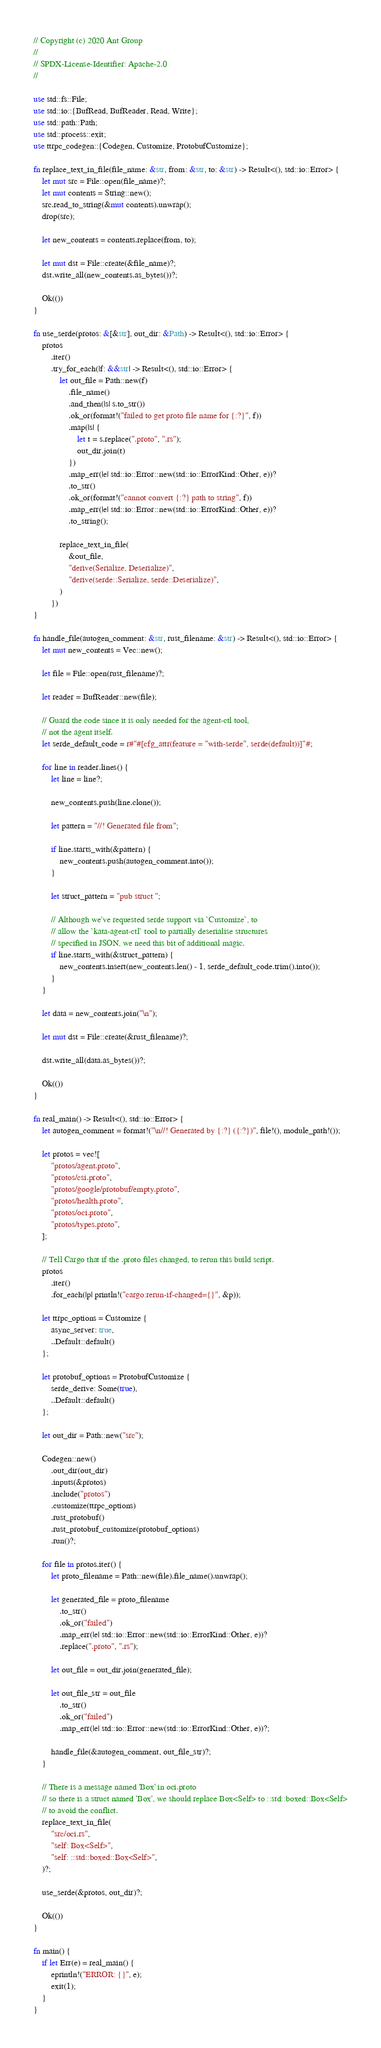Convert code to text. <code><loc_0><loc_0><loc_500><loc_500><_Rust_>// Copyright (c) 2020 Ant Group
//
// SPDX-License-Identifier: Apache-2.0
//

use std::fs::File;
use std::io::{BufRead, BufReader, Read, Write};
use std::path::Path;
use std::process::exit;
use ttrpc_codegen::{Codegen, Customize, ProtobufCustomize};

fn replace_text_in_file(file_name: &str, from: &str, to: &str) -> Result<(), std::io::Error> {
    let mut src = File::open(file_name)?;
    let mut contents = String::new();
    src.read_to_string(&mut contents).unwrap();
    drop(src);

    let new_contents = contents.replace(from, to);

    let mut dst = File::create(&file_name)?;
    dst.write_all(new_contents.as_bytes())?;

    Ok(())
}

fn use_serde(protos: &[&str], out_dir: &Path) -> Result<(), std::io::Error> {
    protos
        .iter()
        .try_for_each(|f: &&str| -> Result<(), std::io::Error> {
            let out_file = Path::new(f)
                .file_name()
                .and_then(|s| s.to_str())
                .ok_or(format!("failed to get proto file name for {:?}", f))
                .map(|s| {
                    let t = s.replace(".proto", ".rs");
                    out_dir.join(t)
                })
                .map_err(|e| std::io::Error::new(std::io::ErrorKind::Other, e))?
                .to_str()
                .ok_or(format!("cannot convert {:?} path to string", f))
                .map_err(|e| std::io::Error::new(std::io::ErrorKind::Other, e))?
                .to_string();

            replace_text_in_file(
                &out_file,
                "derive(Serialize, Deserialize)",
                "derive(serde::Serialize, serde::Deserialize)",
            )
        })
}

fn handle_file(autogen_comment: &str, rust_filename: &str) -> Result<(), std::io::Error> {
    let mut new_contents = Vec::new();

    let file = File::open(rust_filename)?;

    let reader = BufReader::new(file);

    // Guard the code since it is only needed for the agent-ctl tool,
    // not the agent itself.
    let serde_default_code = r#"#[cfg_attr(feature = "with-serde", serde(default))]"#;

    for line in reader.lines() {
        let line = line?;

        new_contents.push(line.clone());

        let pattern = "//! Generated file from";

        if line.starts_with(&pattern) {
            new_contents.push(autogen_comment.into());
        }

        let struct_pattern = "pub struct ";

        // Although we've requested serde support via `Customize`, to
        // allow the `kata-agent-ctl` tool to partially deserialise structures
        // specified in JSON, we need this bit of additional magic.
        if line.starts_with(&struct_pattern) {
            new_contents.insert(new_contents.len() - 1, serde_default_code.trim().into());
        }
    }

    let data = new_contents.join("\n");

    let mut dst = File::create(&rust_filename)?;

    dst.write_all(data.as_bytes())?;

    Ok(())
}

fn real_main() -> Result<(), std::io::Error> {
    let autogen_comment = format!("\n//! Generated by {:?} ({:?})", file!(), module_path!());

    let protos = vec![
        "protos/agent.proto",
        "protos/csi.proto",
        "protos/google/protobuf/empty.proto",
        "protos/health.proto",
        "protos/oci.proto",
        "protos/types.proto",
    ];

    // Tell Cargo that if the .proto files changed, to rerun this build script.
    protos
        .iter()
        .for_each(|p| println!("cargo:rerun-if-changed={}", &p));

    let ttrpc_options = Customize {
        async_server: true,
        ..Default::default()
    };

    let protobuf_options = ProtobufCustomize {
        serde_derive: Some(true),
        ..Default::default()
    };

    let out_dir = Path::new("src");

    Codegen::new()
        .out_dir(out_dir)
        .inputs(&protos)
        .include("protos")
        .customize(ttrpc_options)
        .rust_protobuf()
        .rust_protobuf_customize(protobuf_options)
        .run()?;

    for file in protos.iter() {
        let proto_filename = Path::new(file).file_name().unwrap();

        let generated_file = proto_filename
            .to_str()
            .ok_or("failed")
            .map_err(|e| std::io::Error::new(std::io::ErrorKind::Other, e))?
            .replace(".proto", ".rs");

        let out_file = out_dir.join(generated_file);

        let out_file_str = out_file
            .to_str()
            .ok_or("failed")
            .map_err(|e| std::io::Error::new(std::io::ErrorKind::Other, e))?;

        handle_file(&autogen_comment, out_file_str)?;
    }

    // There is a message named 'Box' in oci.proto
    // so there is a struct named 'Box', we should replace Box<Self> to ::std::boxed::Box<Self>
    // to avoid the conflict.
    replace_text_in_file(
        "src/oci.rs",
        "self: Box<Self>",
        "self: ::std::boxed::Box<Self>",
    )?;

    use_serde(&protos, out_dir)?;

    Ok(())
}

fn main() {
    if let Err(e) = real_main() {
        eprintln!("ERROR: {}", e);
        exit(1);
    }
}
</code> 